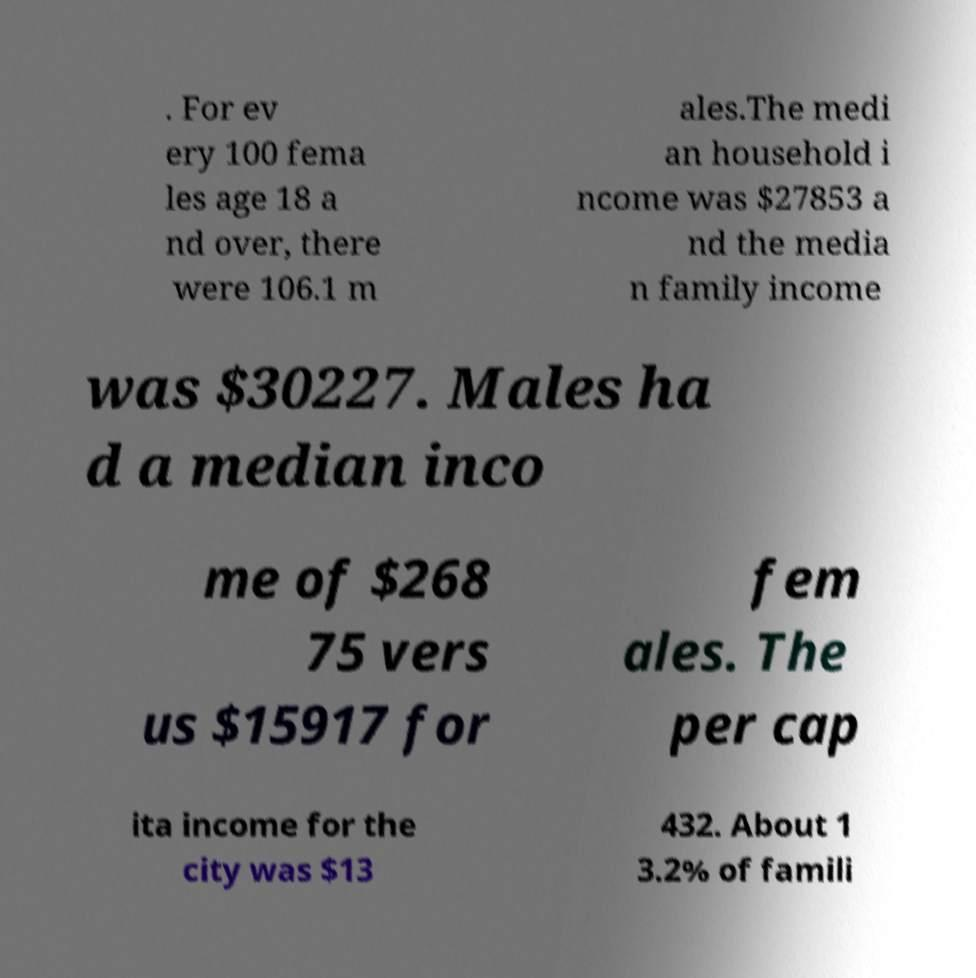For documentation purposes, I need the text within this image transcribed. Could you provide that? . For ev ery 100 fema les age 18 a nd over, there were 106.1 m ales.The medi an household i ncome was $27853 a nd the media n family income was $30227. Males ha d a median inco me of $268 75 vers us $15917 for fem ales. The per cap ita income for the city was $13 432. About 1 3.2% of famili 